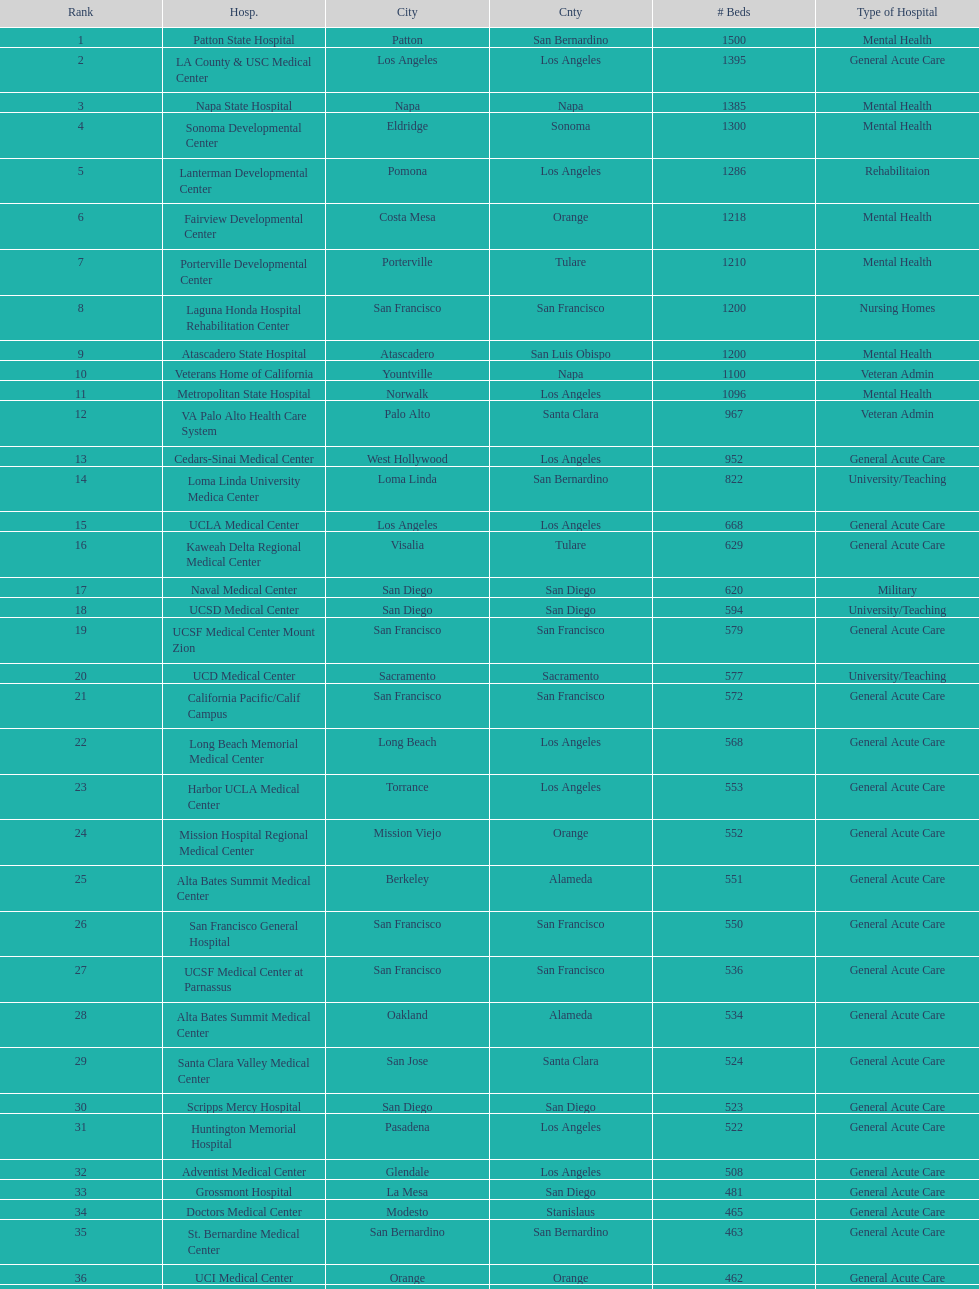How much larger (in number of beds) was the largest hospital in california than the 50th largest? 1071. 